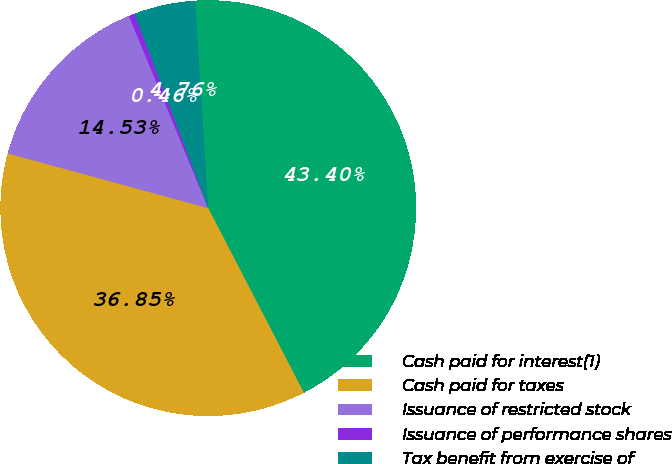<chart> <loc_0><loc_0><loc_500><loc_500><pie_chart><fcel>Cash paid for interest(1)<fcel>Cash paid for taxes<fcel>Issuance of restricted stock<fcel>Issuance of performance shares<fcel>Tax benefit from exercise of<nl><fcel>43.4%<fcel>36.85%<fcel>14.53%<fcel>0.46%<fcel>4.76%<nl></chart> 